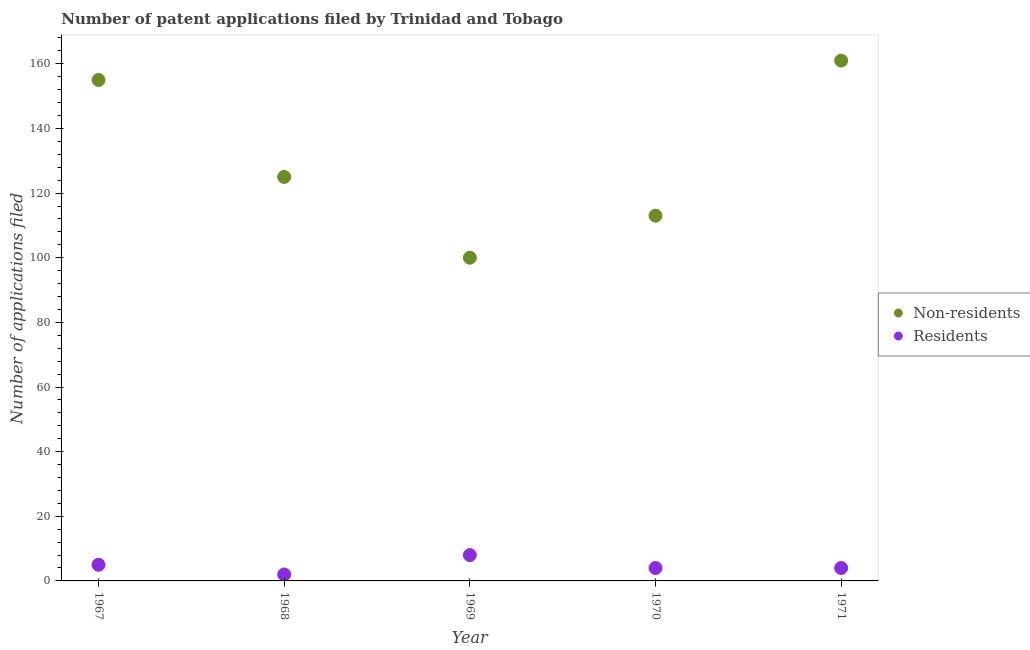How many different coloured dotlines are there?
Your response must be concise. 2. What is the number of patent applications by non residents in 1970?
Your answer should be compact. 113. Across all years, what is the maximum number of patent applications by non residents?
Your answer should be very brief. 161. Across all years, what is the minimum number of patent applications by non residents?
Offer a terse response. 100. In which year was the number of patent applications by non residents maximum?
Offer a terse response. 1971. In which year was the number of patent applications by residents minimum?
Offer a terse response. 1968. What is the total number of patent applications by residents in the graph?
Offer a terse response. 23. What is the difference between the number of patent applications by non residents in 1969 and that in 1971?
Offer a very short reply. -61. What is the difference between the number of patent applications by non residents in 1969 and the number of patent applications by residents in 1967?
Ensure brevity in your answer.  95. What is the average number of patent applications by residents per year?
Provide a short and direct response. 4.6. In the year 1970, what is the difference between the number of patent applications by residents and number of patent applications by non residents?
Offer a terse response. -109. What is the ratio of the number of patent applications by non residents in 1968 to that in 1971?
Your answer should be compact. 0.78. Is the number of patent applications by non residents in 1969 less than that in 1971?
Make the answer very short. Yes. Is the difference between the number of patent applications by non residents in 1968 and 1971 greater than the difference between the number of patent applications by residents in 1968 and 1971?
Your answer should be compact. No. What is the difference between the highest and the lowest number of patent applications by non residents?
Offer a very short reply. 61. Is the sum of the number of patent applications by non residents in 1967 and 1971 greater than the maximum number of patent applications by residents across all years?
Ensure brevity in your answer.  Yes. Is the number of patent applications by residents strictly greater than the number of patent applications by non residents over the years?
Your answer should be compact. No. How many dotlines are there?
Give a very brief answer. 2. Are the values on the major ticks of Y-axis written in scientific E-notation?
Provide a succinct answer. No. How are the legend labels stacked?
Your answer should be compact. Vertical. What is the title of the graph?
Your answer should be compact. Number of patent applications filed by Trinidad and Tobago. What is the label or title of the X-axis?
Your answer should be compact. Year. What is the label or title of the Y-axis?
Provide a succinct answer. Number of applications filed. What is the Number of applications filed in Non-residents in 1967?
Your answer should be compact. 155. What is the Number of applications filed in Non-residents in 1968?
Your response must be concise. 125. What is the Number of applications filed in Residents in 1968?
Provide a succinct answer. 2. What is the Number of applications filed of Residents in 1969?
Your answer should be very brief. 8. What is the Number of applications filed of Non-residents in 1970?
Your response must be concise. 113. What is the Number of applications filed of Non-residents in 1971?
Provide a succinct answer. 161. What is the Number of applications filed of Residents in 1971?
Offer a very short reply. 4. Across all years, what is the maximum Number of applications filed in Non-residents?
Offer a terse response. 161. Across all years, what is the maximum Number of applications filed in Residents?
Offer a very short reply. 8. Across all years, what is the minimum Number of applications filed in Residents?
Your response must be concise. 2. What is the total Number of applications filed in Non-residents in the graph?
Your answer should be very brief. 654. What is the total Number of applications filed of Residents in the graph?
Your response must be concise. 23. What is the difference between the Number of applications filed in Non-residents in 1967 and that in 1968?
Provide a succinct answer. 30. What is the difference between the Number of applications filed in Non-residents in 1967 and that in 1969?
Provide a short and direct response. 55. What is the difference between the Number of applications filed in Residents in 1968 and that in 1969?
Ensure brevity in your answer.  -6. What is the difference between the Number of applications filed in Non-residents in 1968 and that in 1970?
Make the answer very short. 12. What is the difference between the Number of applications filed in Residents in 1968 and that in 1970?
Ensure brevity in your answer.  -2. What is the difference between the Number of applications filed in Non-residents in 1968 and that in 1971?
Offer a terse response. -36. What is the difference between the Number of applications filed in Residents in 1968 and that in 1971?
Your answer should be very brief. -2. What is the difference between the Number of applications filed of Residents in 1969 and that in 1970?
Make the answer very short. 4. What is the difference between the Number of applications filed in Non-residents in 1969 and that in 1971?
Offer a terse response. -61. What is the difference between the Number of applications filed in Non-residents in 1970 and that in 1971?
Your response must be concise. -48. What is the difference between the Number of applications filed of Residents in 1970 and that in 1971?
Offer a terse response. 0. What is the difference between the Number of applications filed in Non-residents in 1967 and the Number of applications filed in Residents in 1968?
Provide a short and direct response. 153. What is the difference between the Number of applications filed of Non-residents in 1967 and the Number of applications filed of Residents in 1969?
Your response must be concise. 147. What is the difference between the Number of applications filed of Non-residents in 1967 and the Number of applications filed of Residents in 1970?
Offer a terse response. 151. What is the difference between the Number of applications filed of Non-residents in 1967 and the Number of applications filed of Residents in 1971?
Your response must be concise. 151. What is the difference between the Number of applications filed in Non-residents in 1968 and the Number of applications filed in Residents in 1969?
Your answer should be very brief. 117. What is the difference between the Number of applications filed of Non-residents in 1968 and the Number of applications filed of Residents in 1970?
Make the answer very short. 121. What is the difference between the Number of applications filed of Non-residents in 1968 and the Number of applications filed of Residents in 1971?
Keep it short and to the point. 121. What is the difference between the Number of applications filed in Non-residents in 1969 and the Number of applications filed in Residents in 1970?
Give a very brief answer. 96. What is the difference between the Number of applications filed in Non-residents in 1969 and the Number of applications filed in Residents in 1971?
Keep it short and to the point. 96. What is the difference between the Number of applications filed in Non-residents in 1970 and the Number of applications filed in Residents in 1971?
Provide a short and direct response. 109. What is the average Number of applications filed in Non-residents per year?
Your response must be concise. 130.8. In the year 1967, what is the difference between the Number of applications filed of Non-residents and Number of applications filed of Residents?
Your answer should be compact. 150. In the year 1968, what is the difference between the Number of applications filed in Non-residents and Number of applications filed in Residents?
Your response must be concise. 123. In the year 1969, what is the difference between the Number of applications filed in Non-residents and Number of applications filed in Residents?
Provide a short and direct response. 92. In the year 1970, what is the difference between the Number of applications filed of Non-residents and Number of applications filed of Residents?
Offer a terse response. 109. In the year 1971, what is the difference between the Number of applications filed of Non-residents and Number of applications filed of Residents?
Your answer should be compact. 157. What is the ratio of the Number of applications filed of Non-residents in 1967 to that in 1968?
Make the answer very short. 1.24. What is the ratio of the Number of applications filed of Non-residents in 1967 to that in 1969?
Your answer should be very brief. 1.55. What is the ratio of the Number of applications filed of Residents in 1967 to that in 1969?
Your answer should be compact. 0.62. What is the ratio of the Number of applications filed in Non-residents in 1967 to that in 1970?
Your answer should be very brief. 1.37. What is the ratio of the Number of applications filed of Residents in 1967 to that in 1970?
Give a very brief answer. 1.25. What is the ratio of the Number of applications filed of Non-residents in 1967 to that in 1971?
Provide a short and direct response. 0.96. What is the ratio of the Number of applications filed of Residents in 1967 to that in 1971?
Your answer should be compact. 1.25. What is the ratio of the Number of applications filed in Non-residents in 1968 to that in 1969?
Ensure brevity in your answer.  1.25. What is the ratio of the Number of applications filed of Residents in 1968 to that in 1969?
Your answer should be very brief. 0.25. What is the ratio of the Number of applications filed of Non-residents in 1968 to that in 1970?
Offer a terse response. 1.11. What is the ratio of the Number of applications filed of Residents in 1968 to that in 1970?
Provide a short and direct response. 0.5. What is the ratio of the Number of applications filed of Non-residents in 1968 to that in 1971?
Offer a very short reply. 0.78. What is the ratio of the Number of applications filed of Non-residents in 1969 to that in 1970?
Provide a short and direct response. 0.89. What is the ratio of the Number of applications filed in Residents in 1969 to that in 1970?
Make the answer very short. 2. What is the ratio of the Number of applications filed of Non-residents in 1969 to that in 1971?
Offer a terse response. 0.62. What is the ratio of the Number of applications filed of Non-residents in 1970 to that in 1971?
Keep it short and to the point. 0.7. What is the ratio of the Number of applications filed in Residents in 1970 to that in 1971?
Offer a very short reply. 1. What is the difference between the highest and the lowest Number of applications filed in Non-residents?
Offer a terse response. 61. What is the difference between the highest and the lowest Number of applications filed in Residents?
Provide a short and direct response. 6. 